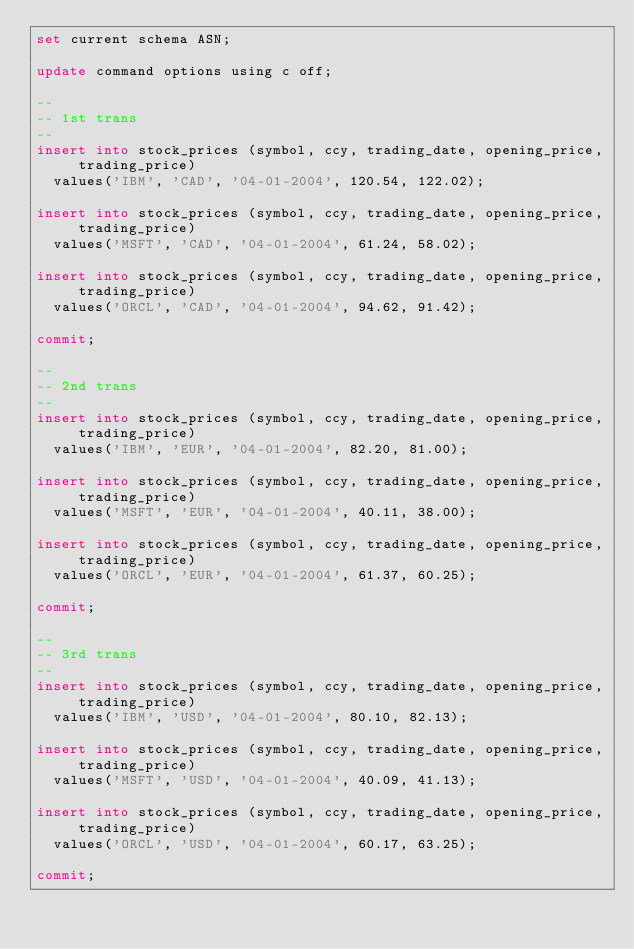Convert code to text. <code><loc_0><loc_0><loc_500><loc_500><_SQL_>set current schema ASN;

update command options using c off;

--
-- 1st trans
--
insert into stock_prices (symbol, ccy, trading_date, opening_price, trading_price)
	values('IBM', 'CAD', '04-01-2004', 120.54, 122.02);

insert into stock_prices (symbol, ccy, trading_date, opening_price, trading_price)
	values('MSFT', 'CAD', '04-01-2004', 61.24, 58.02);

insert into stock_prices (symbol, ccy, trading_date, opening_price, trading_price)
	values('ORCL', 'CAD', '04-01-2004', 94.62, 91.42);

commit;

--
-- 2nd trans
--
insert into stock_prices (symbol, ccy, trading_date, opening_price, trading_price)
	values('IBM', 'EUR', '04-01-2004', 82.20, 81.00);

insert into stock_prices (symbol, ccy, trading_date, opening_price, trading_price)
	values('MSFT', 'EUR', '04-01-2004', 40.11, 38.00);

insert into stock_prices (symbol, ccy, trading_date, opening_price, trading_price)
	values('ORCL', 'EUR', '04-01-2004', 61.37, 60.25);

commit;

--
-- 3rd trans
--
insert into stock_prices (symbol, ccy, trading_date, opening_price, trading_price)
	values('IBM', 'USD', '04-01-2004', 80.10, 82.13);

insert into stock_prices (symbol, ccy, trading_date, opening_price, trading_price)
	values('MSFT', 'USD', '04-01-2004', 40.09, 41.13);

insert into stock_prices (symbol, ccy, trading_date, opening_price, trading_price)
	values('ORCL', 'USD', '04-01-2004', 60.17, 63.25);

commit;
</code> 